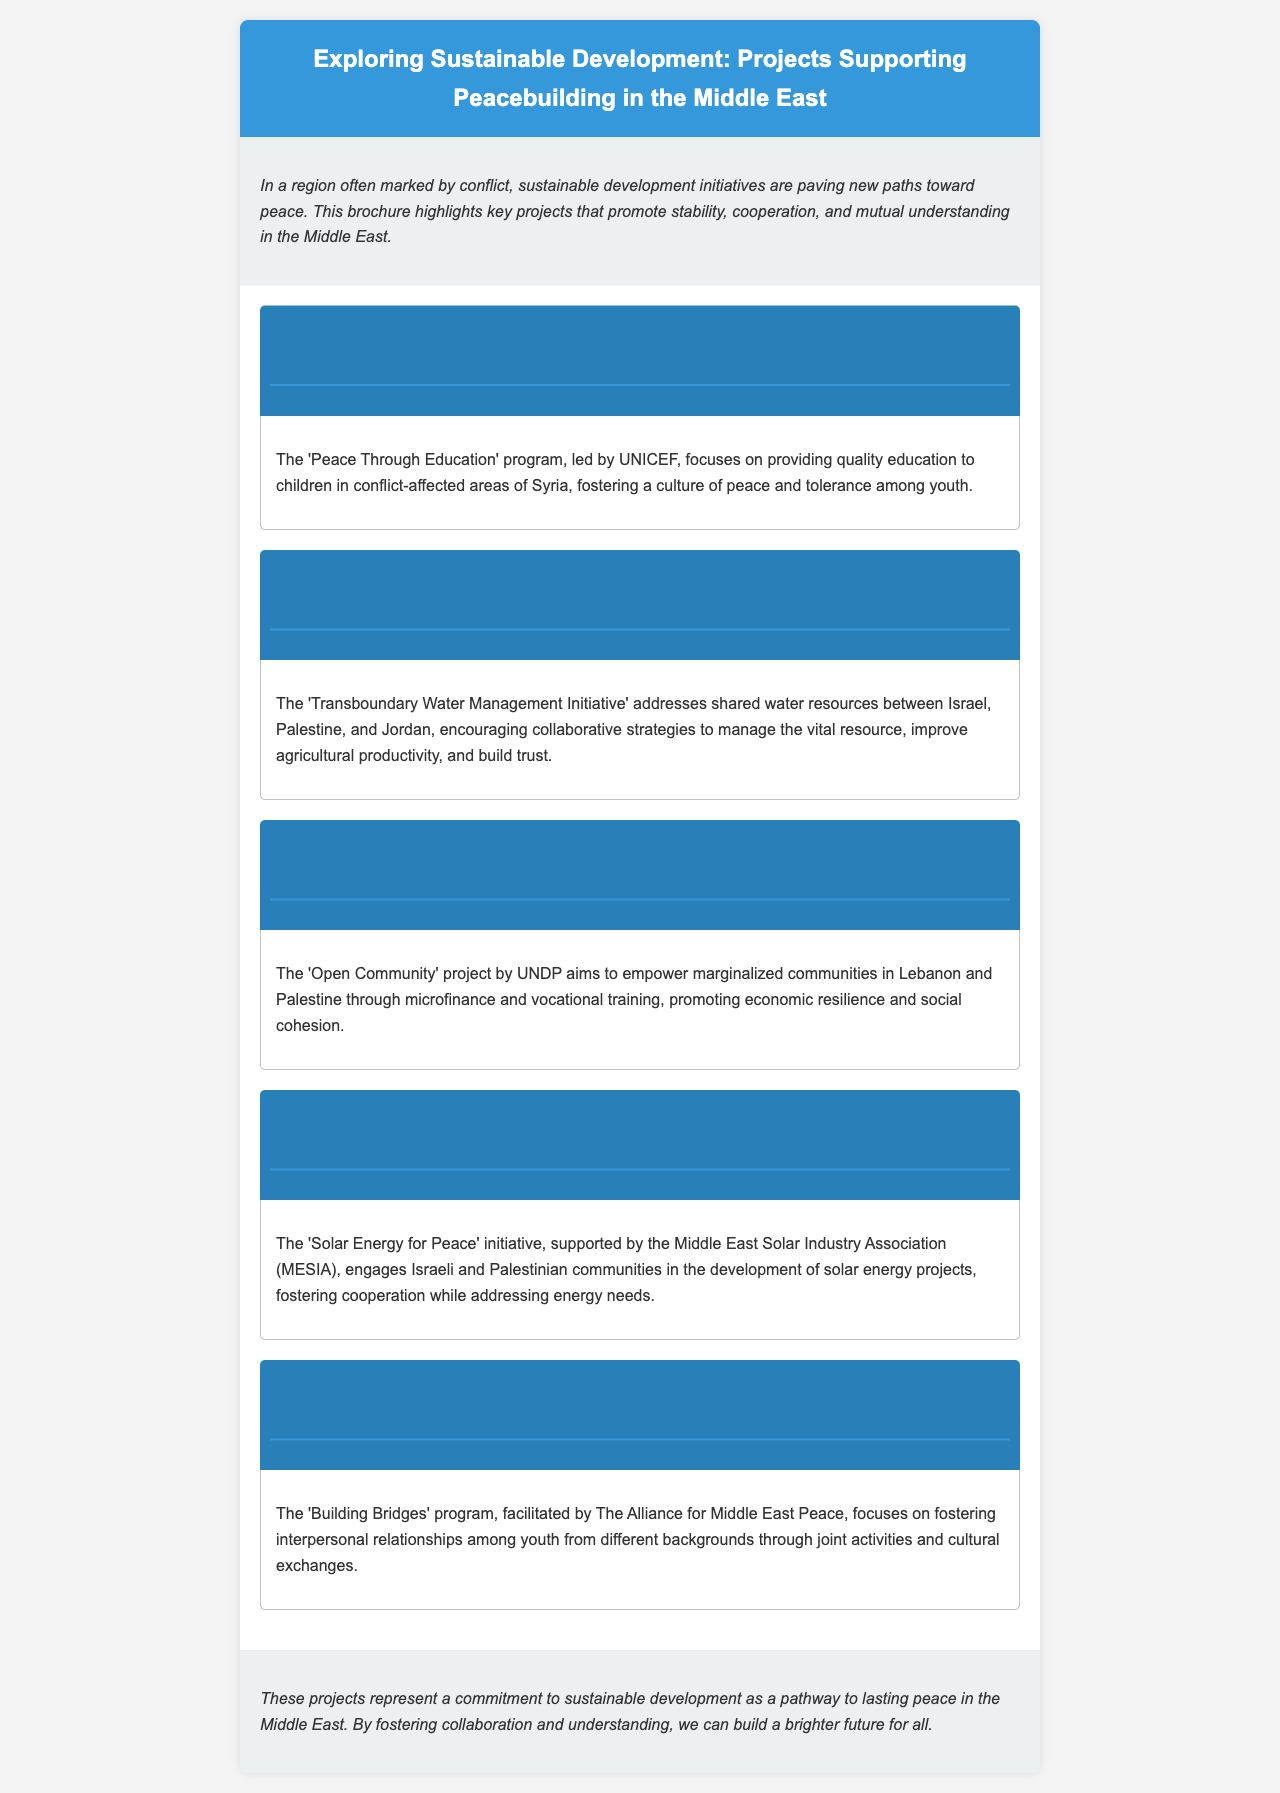What is the main theme of the brochure? The brochure highlights key projects that promote stability, cooperation, and mutual understanding in the Middle East.
Answer: Sustainable development Who leads the 'Peace Through Education' program? The document specifies that the program is led by UNICEF.
Answer: UNICEF Which initiative addresses shared water resources among Israel, Palestine, and Jordan? It is mentioned as the 'Transboundary Water Management Initiative'.
Answer: Transboundary Water Management Initiative What is the goal of the 'Open Community' project by UNDP? The project aims to empower marginalized communities in Lebanon and Palestine.
Answer: Empower marginalized communities Which energy project involves Israeli and Palestinian communities? It is referred to as the 'Solar Energy for Peace' initiative.
Answer: Solar Energy for Peace What does the 'Building Bridges' program focus on? The program focuses on fostering interpersonal relationships among youth from different backgrounds.
Answer: Interpersonal relationships among youth How many main sections are there in the document? The document contains five main sections detailing different initiatives.
Answer: Five What type of document is this? The content and structure indicate it is a brochure.
Answer: Brochure 